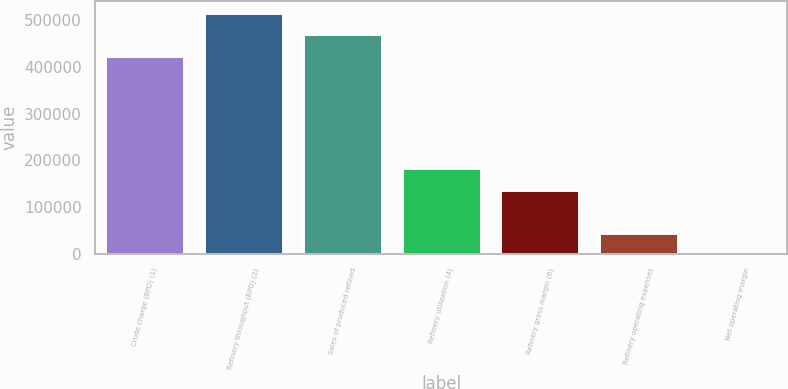Convert chart to OTSL. <chart><loc_0><loc_0><loc_500><loc_500><bar_chart><fcel>Crude charge (BPD) (1)<fcel>Refinery throughput (BPD) (2)<fcel>Sales of produced refined<fcel>Refinery utilization (4)<fcel>Refinery gross margin (6)<fcel>Refinery operating expenses<fcel>Net operating margin<nl><fcel>423910<fcel>515406<fcel>469658<fcel>182994<fcel>137246<fcel>45750.3<fcel>2.52<nl></chart> 